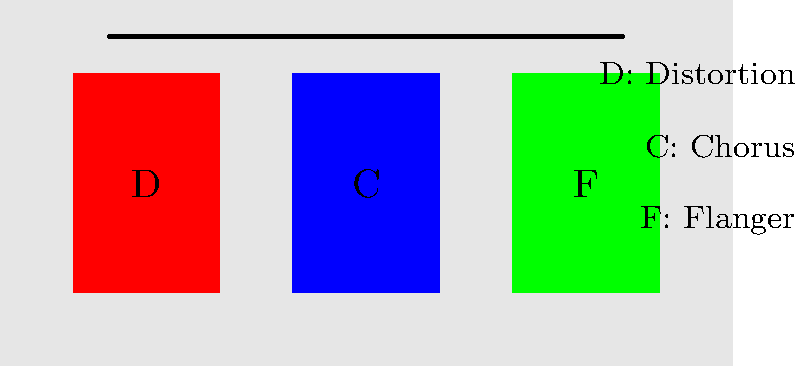In the image recognition problem for detecting effects pedals in a pedalboard setup, which machine learning technique would be most suitable for identifying the specific types and order of pedals shown in the diagram, and why might this be challenging for a rock purist who values the raw sound of an electric guitar? To solve this image recognition problem, we need to consider several factors:

1. Object Detection: We need to identify individual pedals on the pedalboard.
2. Classification: Each pedal needs to be classified according to its type (e.g., Distortion, Chorus, Flanger).
3. Spatial Relationship: The order of pedals is important in determining the signal chain.

Given these requirements, a Convolutional Neural Network (CNN) with an architecture like Faster R-CNN or YOLO (You Only Look Once) would be most suitable. Here's why:

1. CNNs are excellent at extracting features from images, which is crucial for identifying pedal shapes and characteristics.
2. Faster R-CNN and YOLO can perform both object detection and classification in a single forward pass, making them efficient for this task.
3. These architectures can also maintain spatial information, allowing us to determine the order of pedals in the signal chain.

The challenge for a rock purist lies in the following aspects:

1. Pedal Variety: There's a vast array of pedal types and brands, making classification complex.
2. Customization: Many guitarists modify their pedals, potentially altering their appearance.
3. Lighting Conditions: Stage lighting can affect pedal appearance in live settings.
4. Philosophical Conflict: A purist might argue that relying on AI to analyze a pedalboard goes against the organic nature of creating rock music.

For a rock purist who values raw electric guitar sound, this technology might seem unnecessary or even contradictory to their ethos. They might argue that true rock 'n' roll is about feel and intuition rather than precise analysis of effects. However, understanding this technology could help in recreating specific tones or troubleshooting signal chain issues, even for those who prefer a more straightforward approach to their sound.
Answer: Convolutional Neural Network (CNN) with Faster R-CNN or YOLO architecture 